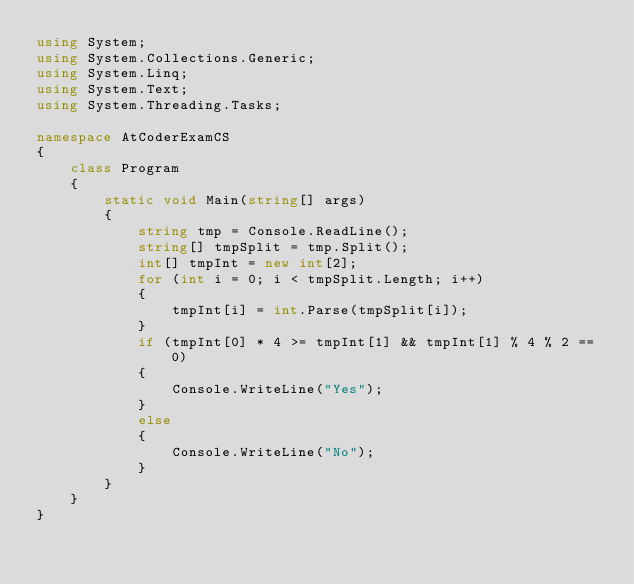<code> <loc_0><loc_0><loc_500><loc_500><_C#_>using System;
using System.Collections.Generic;
using System.Linq;
using System.Text;
using System.Threading.Tasks;

namespace AtCoderExamCS
{
    class Program
    {
        static void Main(string[] args)
        {
            string tmp = Console.ReadLine();
            string[] tmpSplit = tmp.Split();
            int[] tmpInt = new int[2];
            for (int i = 0; i < tmpSplit.Length; i++)
            {
                tmpInt[i] = int.Parse(tmpSplit[i]);
            }
            if (tmpInt[0] * 4 >= tmpInt[1] && tmpInt[1] % 4 % 2 == 0)
            {
                Console.WriteLine("Yes");
            }
            else
            {
                Console.WriteLine("No");
            }
        }
    }
}
</code> 